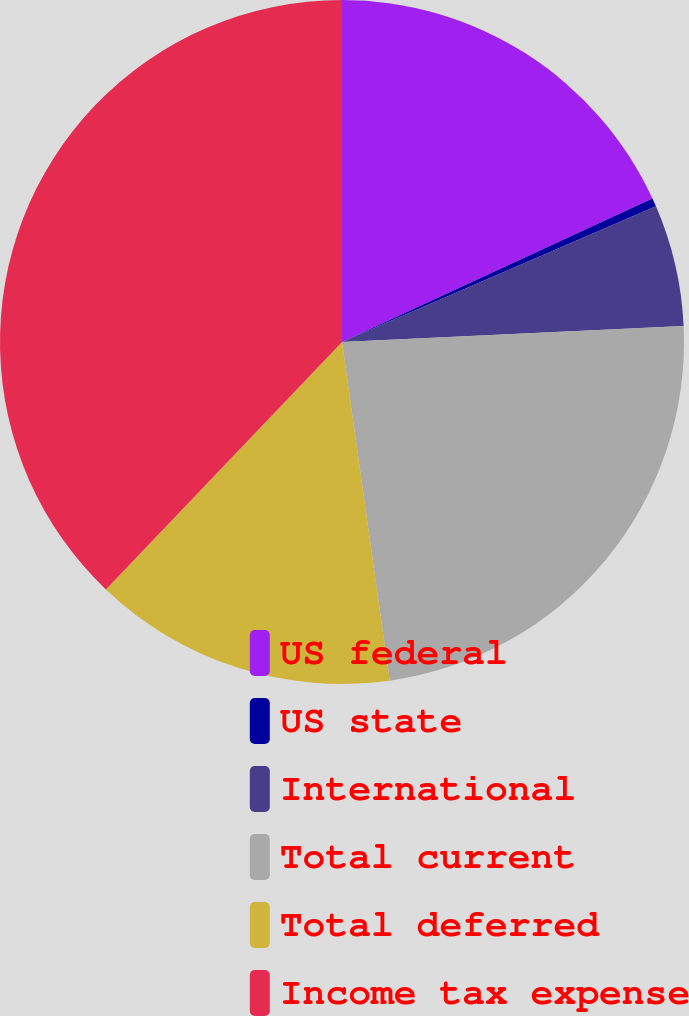<chart> <loc_0><loc_0><loc_500><loc_500><pie_chart><fcel>US federal<fcel>US state<fcel>International<fcel>Total current<fcel>Total deferred<fcel>Income tax expense<nl><fcel>18.11%<fcel>0.4%<fcel>5.75%<fcel>23.51%<fcel>14.36%<fcel>37.87%<nl></chart> 